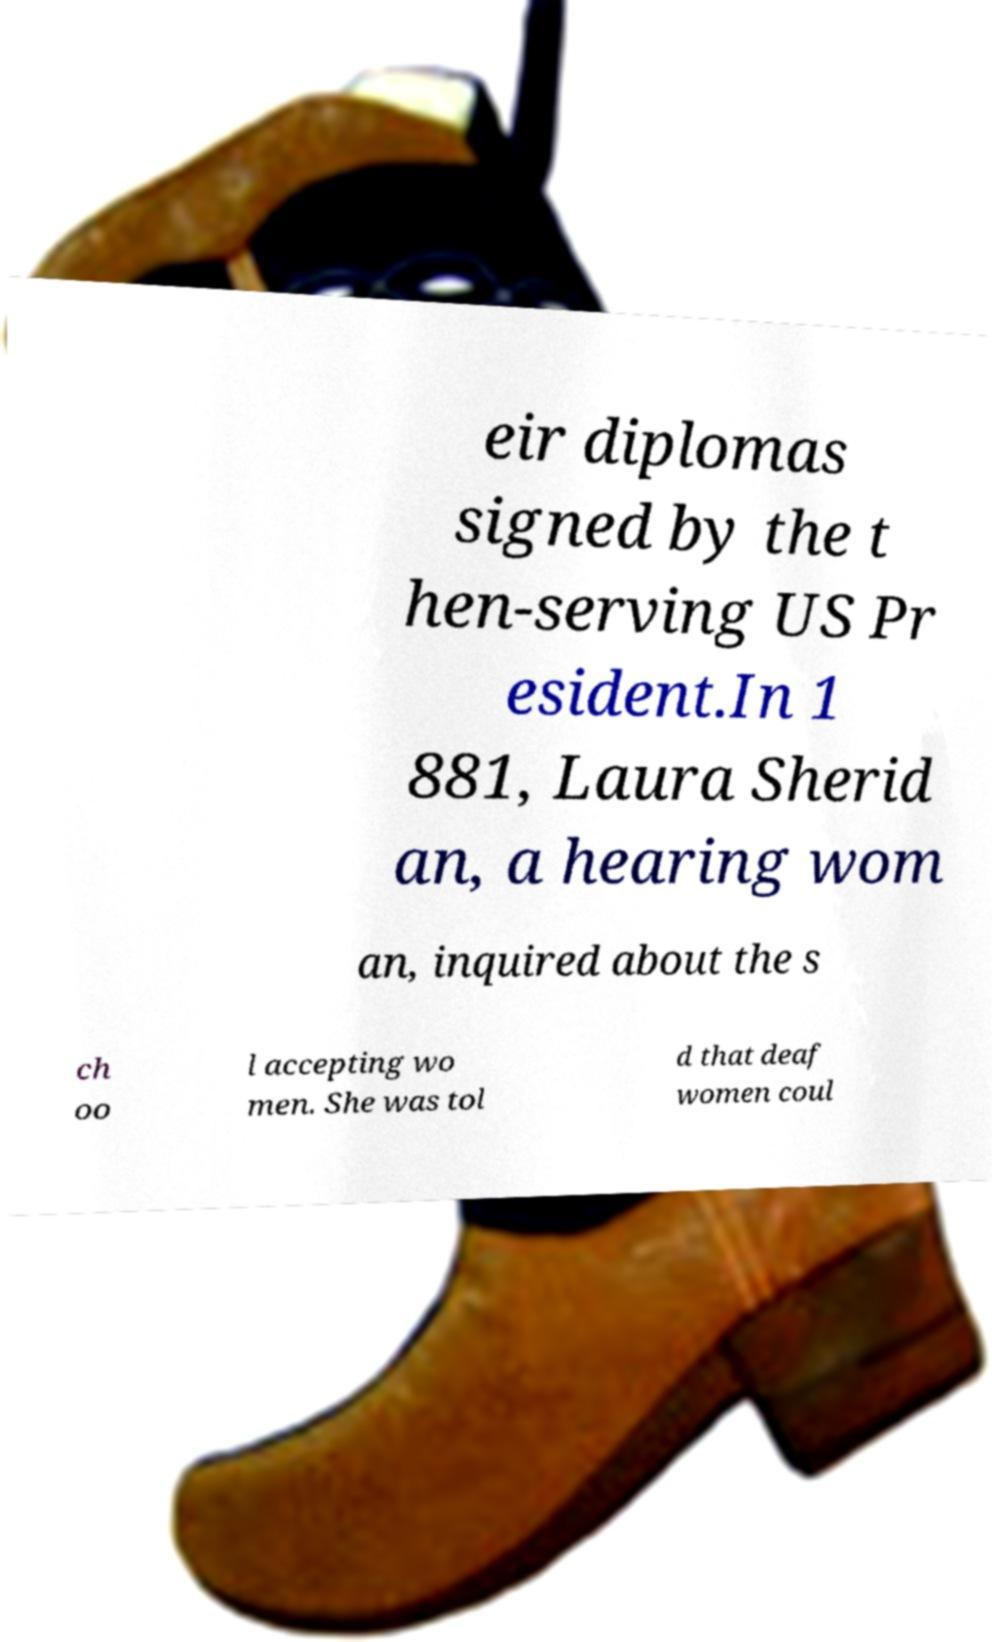Can you read and provide the text displayed in the image?This photo seems to have some interesting text. Can you extract and type it out for me? eir diplomas signed by the t hen-serving US Pr esident.In 1 881, Laura Sherid an, a hearing wom an, inquired about the s ch oo l accepting wo men. She was tol d that deaf women coul 